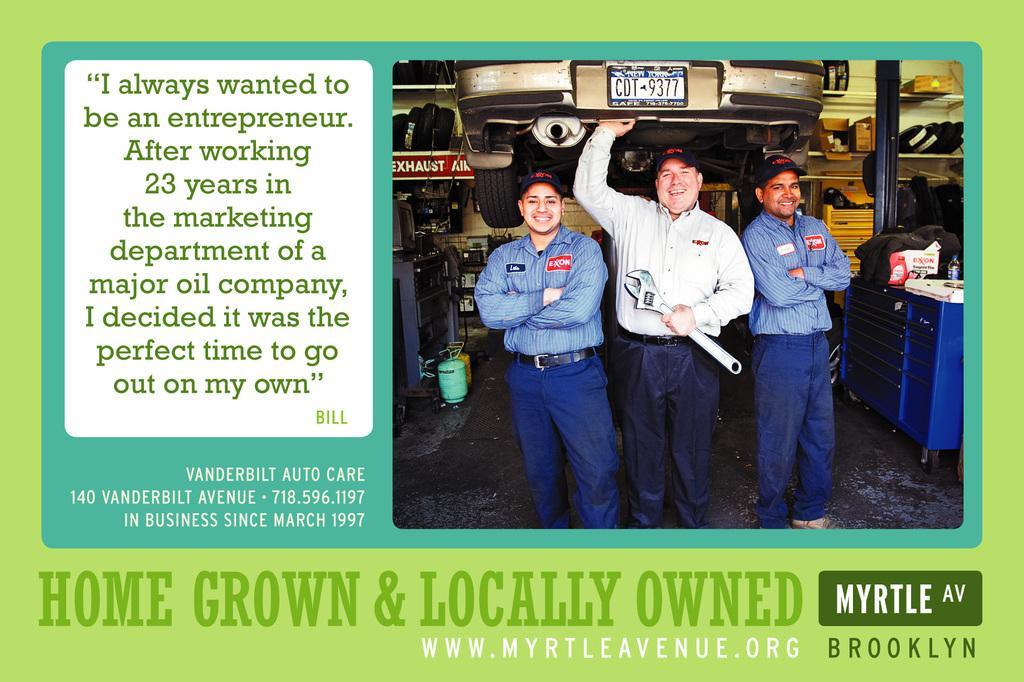Describe this image in one or two sentences. In this image we can see an advertisement. In the advertisement there are the pictures of cardboard cartons, motor vehicles, spare parts, persons standing on the floor and bags. 